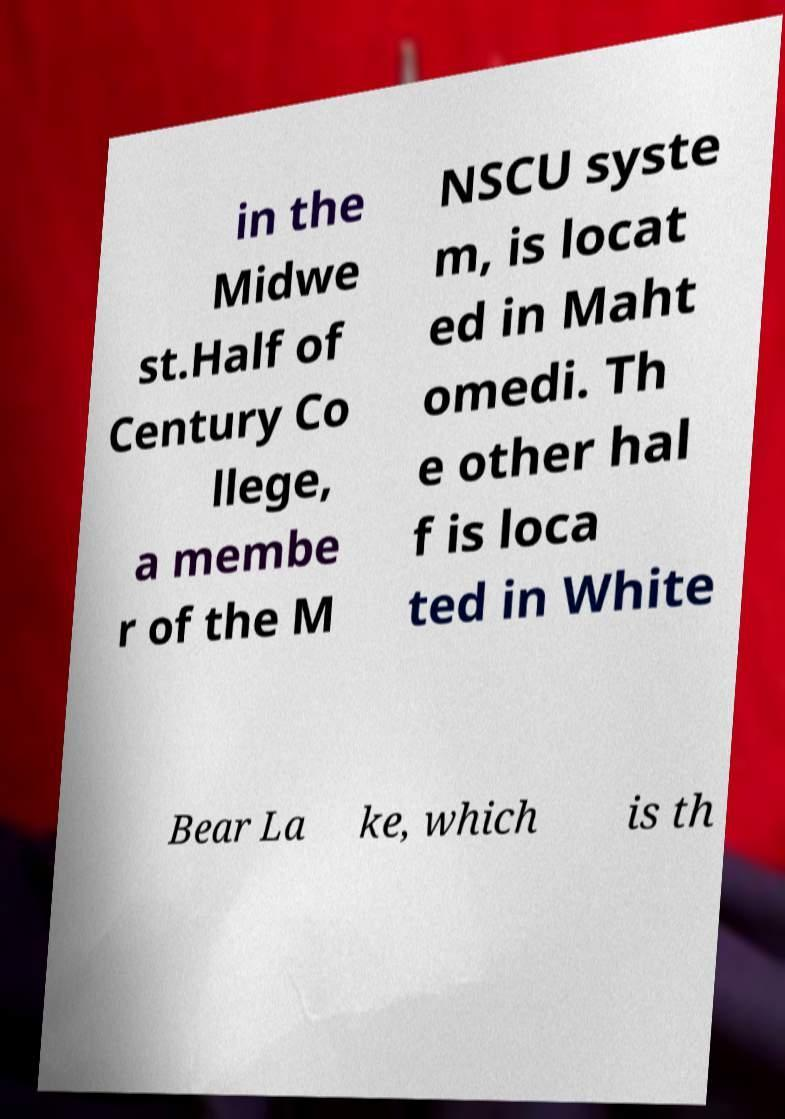Please identify and transcribe the text found in this image. in the Midwe st.Half of Century Co llege, a membe r of the M NSCU syste m, is locat ed in Maht omedi. Th e other hal f is loca ted in White Bear La ke, which is th 